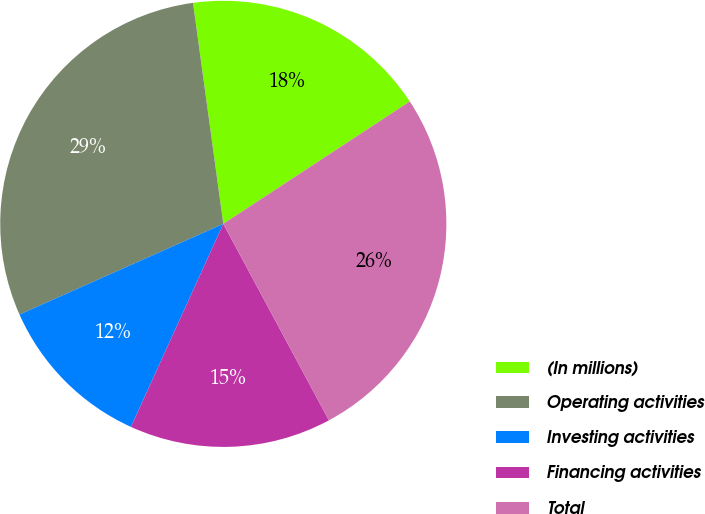Convert chart. <chart><loc_0><loc_0><loc_500><loc_500><pie_chart><fcel>(In millions)<fcel>Operating activities<fcel>Investing activities<fcel>Financing activities<fcel>Total<nl><fcel>17.92%<fcel>29.49%<fcel>11.54%<fcel>14.64%<fcel>26.39%<nl></chart> 